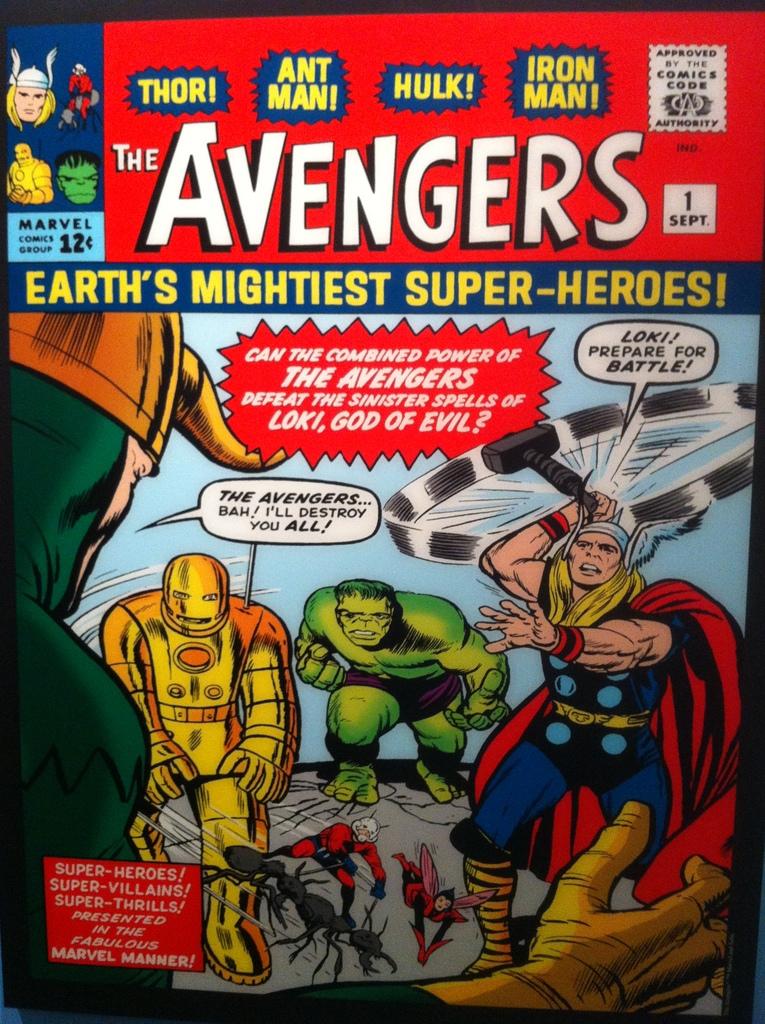Who are earth's mightiest super-heroes?
Your answer should be very brief. The avengers. Is the ant man in this comic?
Keep it short and to the point. Yes. 